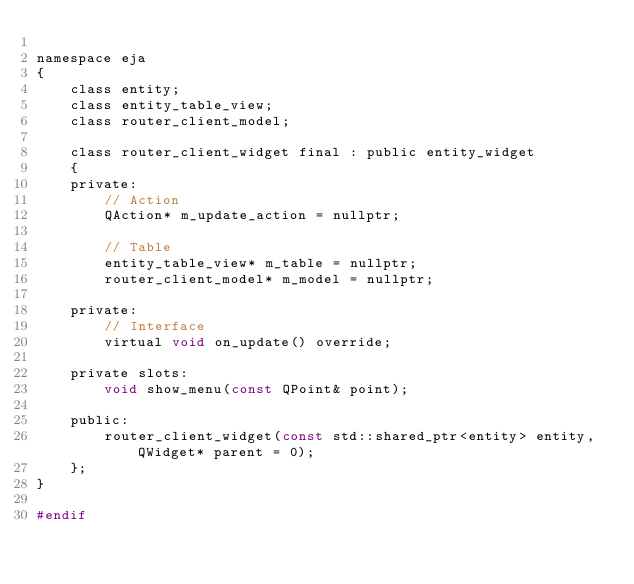Convert code to text. <code><loc_0><loc_0><loc_500><loc_500><_C_>
namespace eja
{
	class entity;
	class entity_table_view;
	class router_client_model;

	class router_client_widget final : public entity_widget
	{
	private:
		// Action
		QAction* m_update_action = nullptr;

		// Table
		entity_table_view* m_table = nullptr;
		router_client_model* m_model = nullptr;

	private:
		// Interface
		virtual void on_update() override;

	private slots:
		void show_menu(const QPoint& point);

	public:
		router_client_widget(const std::shared_ptr<entity> entity, QWidget* parent = 0);
	};
}

#endif
</code> 